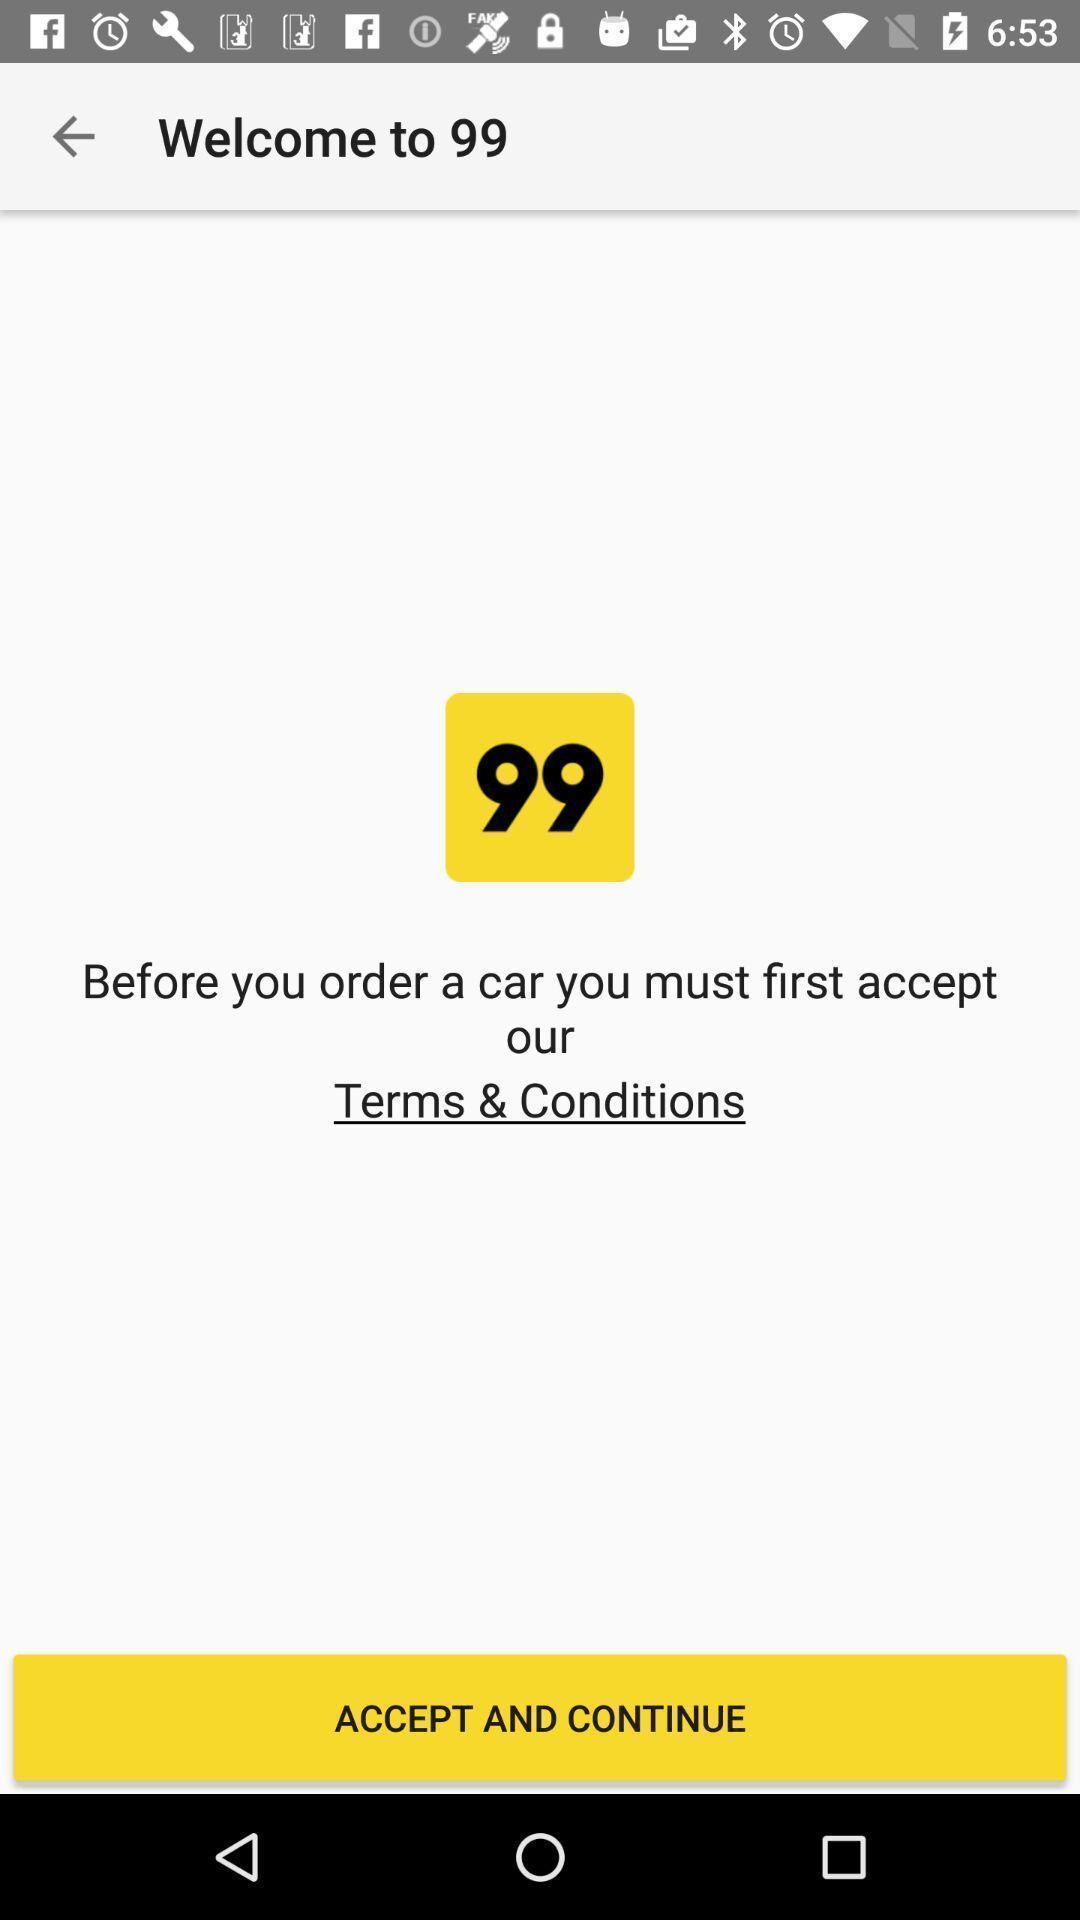Summarize the information in this screenshot. Welcome page for accepting terms and conditions. 